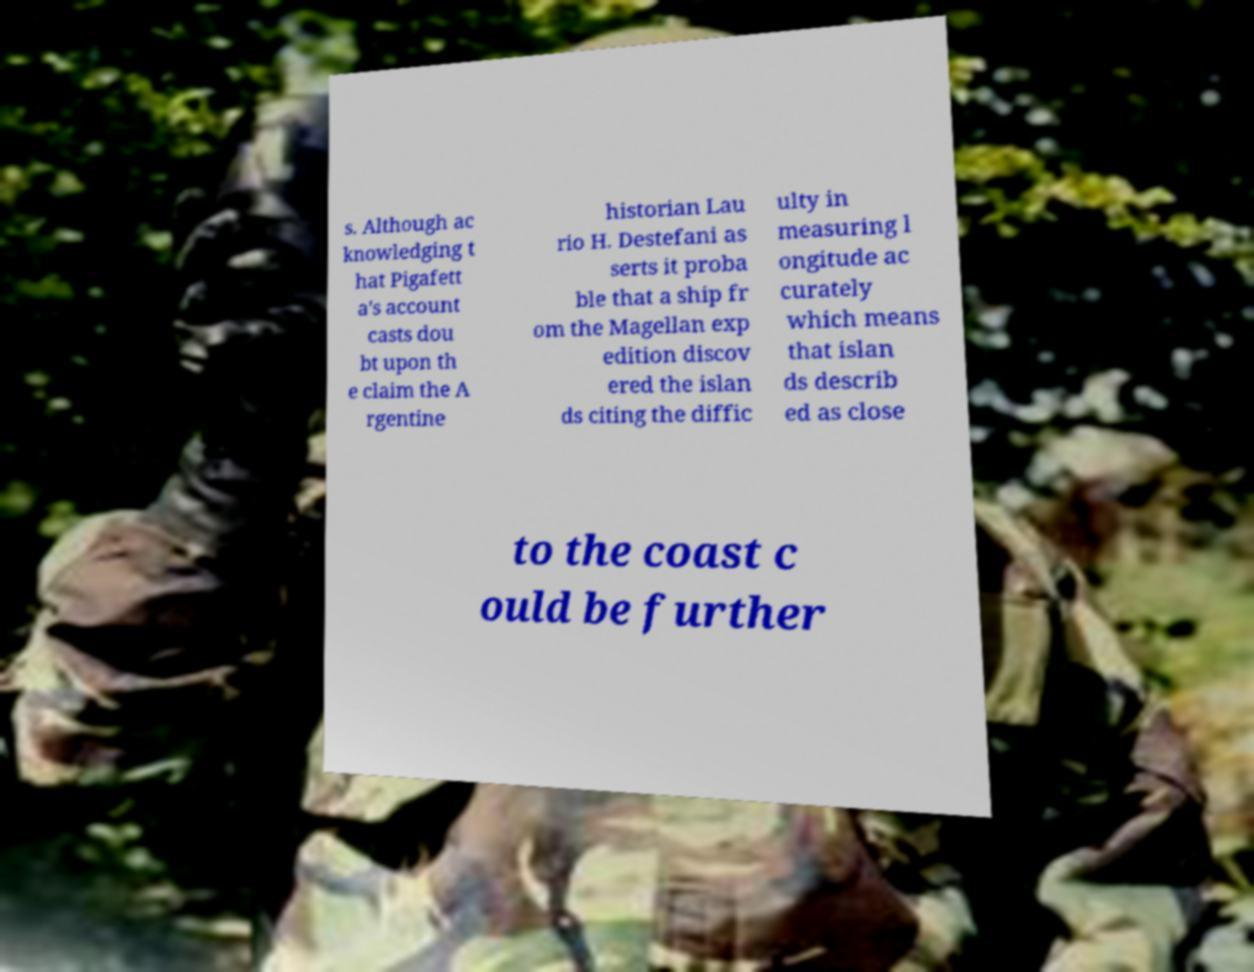Please read and relay the text visible in this image. What does it say? s. Although ac knowledging t hat Pigafett a's account casts dou bt upon th e claim the A rgentine historian Lau rio H. Destefani as serts it proba ble that a ship fr om the Magellan exp edition discov ered the islan ds citing the diffic ulty in measuring l ongitude ac curately which means that islan ds describ ed as close to the coast c ould be further 